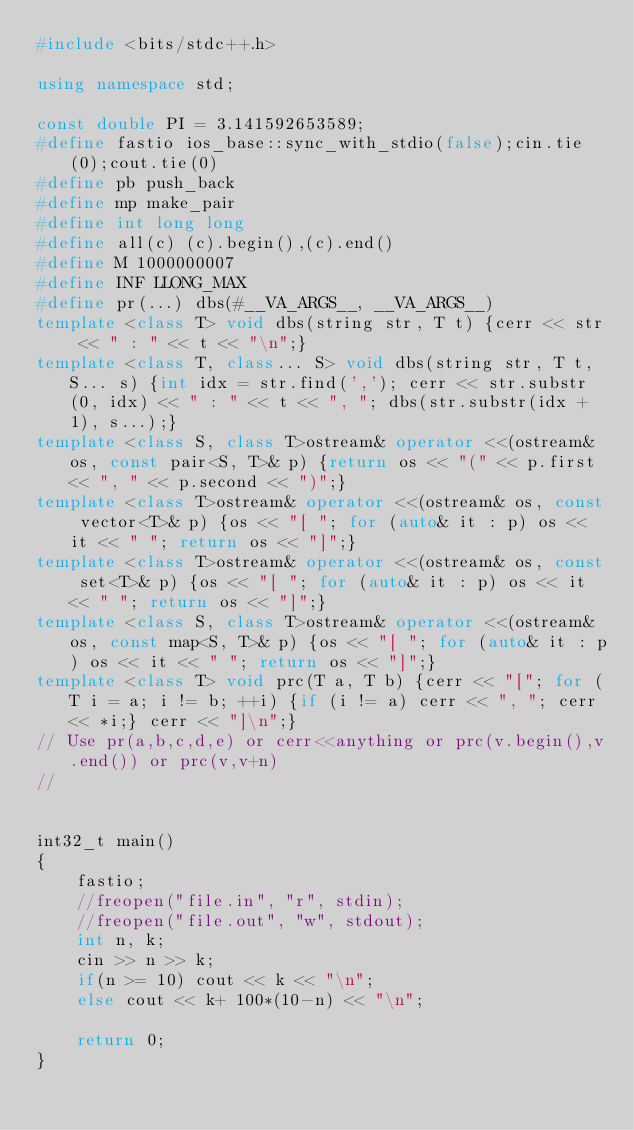<code> <loc_0><loc_0><loc_500><loc_500><_C++_>#include <bits/stdc++.h>

using namespace std;

const double PI = 3.141592653589;
#define fastio ios_base::sync_with_stdio(false);cin.tie(0);cout.tie(0)
#define pb push_back
#define mp make_pair
#define int long long
#define all(c) (c).begin(),(c).end()
#define M 1000000007
#define INF LLONG_MAX
#define pr(...) dbs(#__VA_ARGS__, __VA_ARGS__)
template <class T> void dbs(string str, T t) {cerr << str << " : " << t << "\n";}
template <class T, class... S> void dbs(string str, T t, S... s) {int idx = str.find(','); cerr << str.substr(0, idx) << " : " << t << ", "; dbs(str.substr(idx + 1), s...);}
template <class S, class T>ostream& operator <<(ostream& os, const pair<S, T>& p) {return os << "(" << p.first << ", " << p.second << ")";}
template <class T>ostream& operator <<(ostream& os, const vector<T>& p) {os << "[ "; for (auto& it : p) os << it << " "; return os << "]";}
template <class T>ostream& operator <<(ostream& os, const set<T>& p) {os << "[ "; for (auto& it : p) os << it << " "; return os << "]";}
template <class S, class T>ostream& operator <<(ostream& os, const map<S, T>& p) {os << "[ "; for (auto& it : p) os << it << " "; return os << "]";}
template <class T> void prc(T a, T b) {cerr << "["; for (T i = a; i != b; ++i) {if (i != a) cerr << ", "; cerr << *i;} cerr << "]\n";}
// Use pr(a,b,c,d,e) or cerr<<anything or prc(v.begin(),v.end()) or prc(v,v+n)
//  


int32_t main()
{
    fastio;
    //freopen("file.in", "r", stdin);
    //freopen("file.out", "w", stdout);
    int n, k;
    cin >> n >> k;
    if(n >= 10) cout << k << "\n";
    else cout << k+ 100*(10-n) << "\n";

    return 0;
}

</code> 